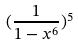Convert formula to latex. <formula><loc_0><loc_0><loc_500><loc_500>( \frac { 1 } { 1 - x ^ { 6 } } ) ^ { 5 }</formula> 